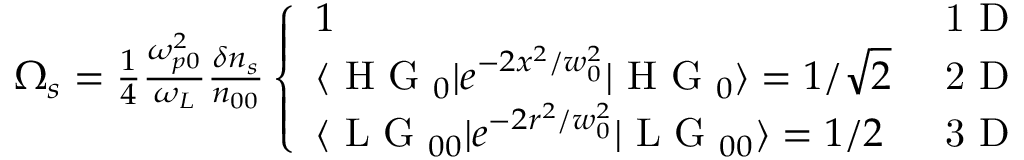<formula> <loc_0><loc_0><loc_500><loc_500>\begin{array} { r } { \Omega _ { s } = \frac { 1 } { 4 } \frac { \omega _ { p 0 } ^ { 2 } } { \omega _ { L } } \frac { \delta n _ { s } } { n _ { 0 0 } } \left \{ \begin{array} { l l } { 1 } & { 1 D } \\ { \langle H G _ { 0 } | e ^ { - 2 x ^ { 2 } / w _ { 0 } ^ { 2 } } | H G _ { 0 } \rangle = 1 / \sqrt { 2 } } & { 2 D } \\ { \langle L G _ { 0 0 } | e ^ { - 2 r ^ { 2 } / w _ { 0 } ^ { 2 } } | L G _ { 0 0 } \rangle = 1 / 2 } & { 3 D } \end{array} } \end{array}</formula> 